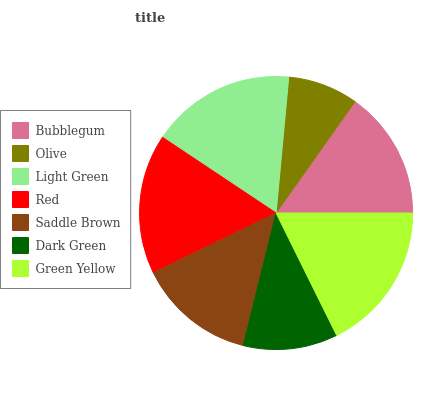Is Olive the minimum?
Answer yes or no. Yes. Is Green Yellow the maximum?
Answer yes or no. Yes. Is Light Green the minimum?
Answer yes or no. No. Is Light Green the maximum?
Answer yes or no. No. Is Light Green greater than Olive?
Answer yes or no. Yes. Is Olive less than Light Green?
Answer yes or no. Yes. Is Olive greater than Light Green?
Answer yes or no. No. Is Light Green less than Olive?
Answer yes or no. No. Is Bubblegum the high median?
Answer yes or no. Yes. Is Bubblegum the low median?
Answer yes or no. Yes. Is Green Yellow the high median?
Answer yes or no. No. Is Light Green the low median?
Answer yes or no. No. 